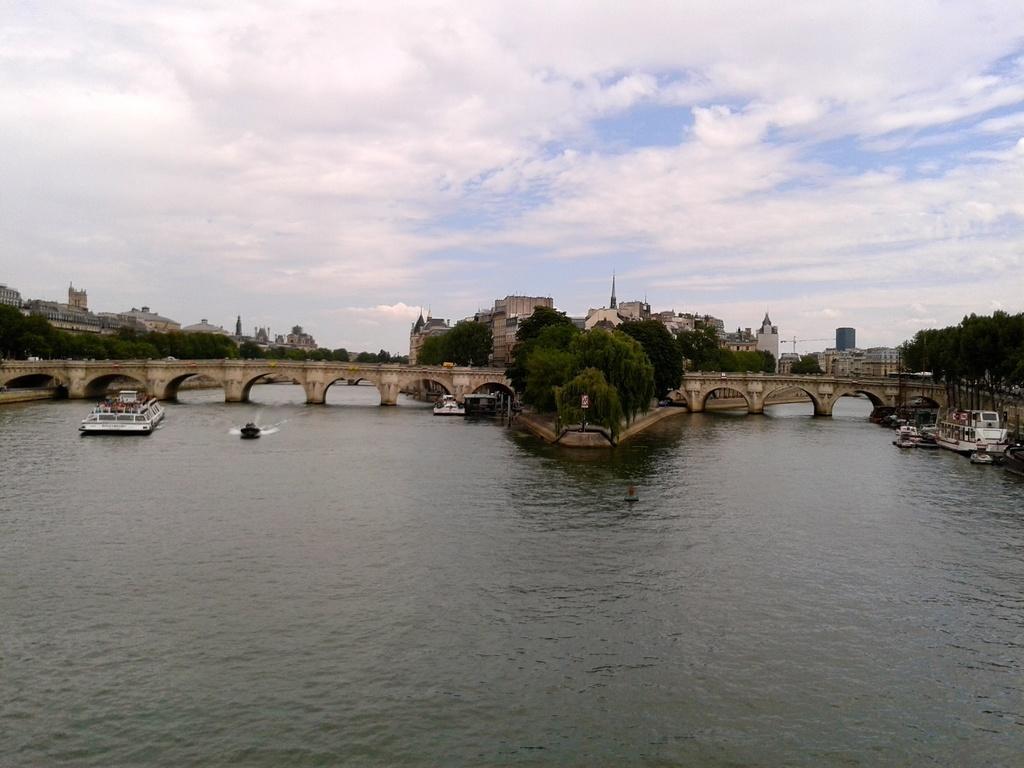Could you give a brief overview of what you see in this image? In this picture we can observe a river. There are some ships and a boat floating on the water. We can observe a bridge over this river. There are some trees in this picture. In the background there are buildings and a sky with clouds. 